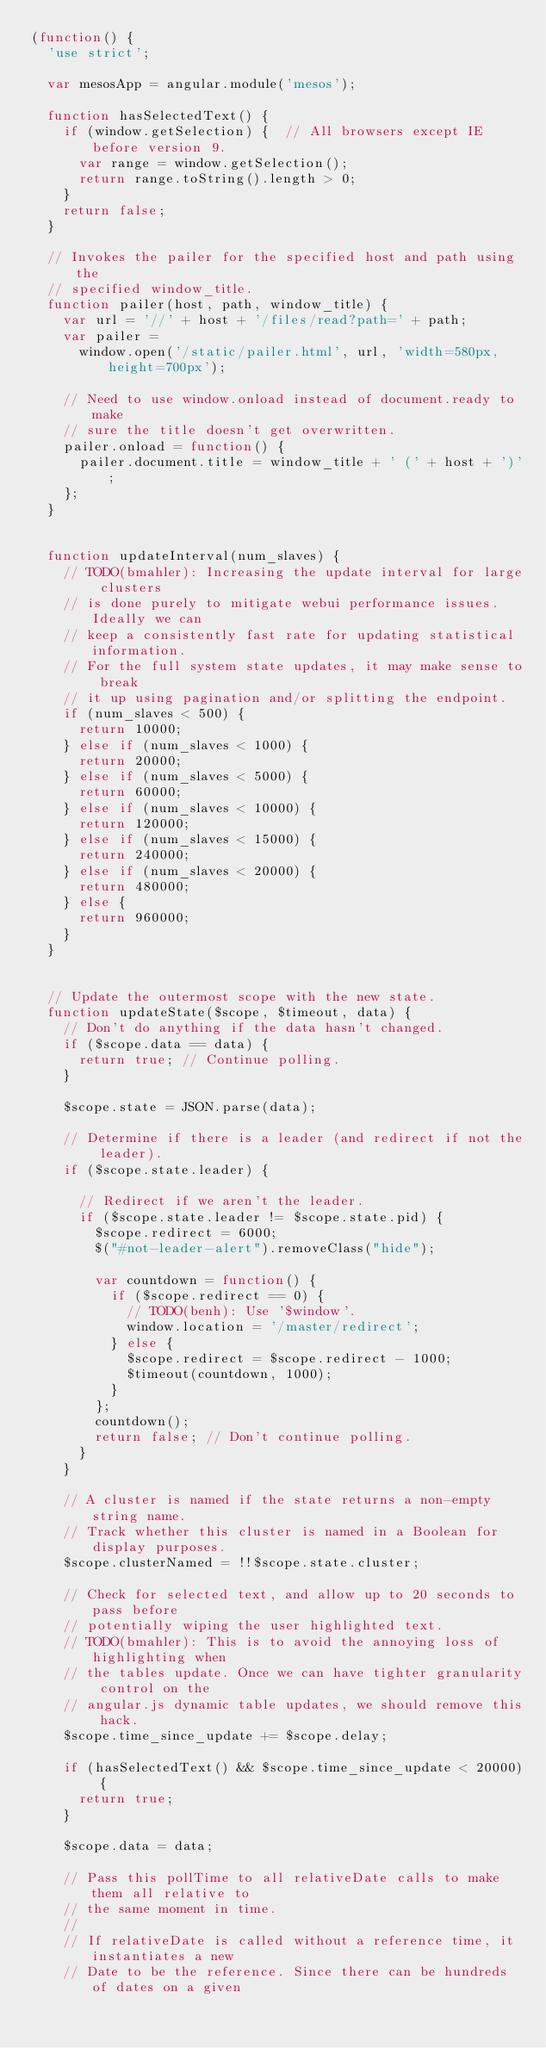<code> <loc_0><loc_0><loc_500><loc_500><_JavaScript_>(function() {
  'use strict';

  var mesosApp = angular.module('mesos');

  function hasSelectedText() {
    if (window.getSelection) {  // All browsers except IE before version 9.
      var range = window.getSelection();
      return range.toString().length > 0;
    }
    return false;
  }

  // Invokes the pailer for the specified host and path using the
  // specified window_title.
  function pailer(host, path, window_title) {
    var url = '//' + host + '/files/read?path=' + path;
    var pailer =
      window.open('/static/pailer.html', url, 'width=580px, height=700px');

    // Need to use window.onload instead of document.ready to make
    // sure the title doesn't get overwritten.
    pailer.onload = function() {
      pailer.document.title = window_title + ' (' + host + ')';
    };
  }


  function updateInterval(num_slaves) {
    // TODO(bmahler): Increasing the update interval for large clusters
    // is done purely to mitigate webui performance issues. Ideally we can
    // keep a consistently fast rate for updating statistical information.
    // For the full system state updates, it may make sense to break
    // it up using pagination and/or splitting the endpoint.
    if (num_slaves < 500) {
      return 10000;
    } else if (num_slaves < 1000) {
      return 20000;
    } else if (num_slaves < 5000) {
      return 60000;
    } else if (num_slaves < 10000) {
      return 120000;
    } else if (num_slaves < 15000) {
      return 240000;
    } else if (num_slaves < 20000) {
      return 480000;
    } else {
      return 960000;
    }
  }


  // Update the outermost scope with the new state.
  function updateState($scope, $timeout, data) {
    // Don't do anything if the data hasn't changed.
    if ($scope.data == data) {
      return true; // Continue polling.
    }

    $scope.state = JSON.parse(data);

    // Determine if there is a leader (and redirect if not the leader).
    if ($scope.state.leader) {

      // Redirect if we aren't the leader.
      if ($scope.state.leader != $scope.state.pid) {
        $scope.redirect = 6000;
        $("#not-leader-alert").removeClass("hide");

        var countdown = function() {
          if ($scope.redirect == 0) {
            // TODO(benh): Use '$window'.
            window.location = '/master/redirect';
          } else {
            $scope.redirect = $scope.redirect - 1000;
            $timeout(countdown, 1000);
          }
        };
        countdown();
        return false; // Don't continue polling.
      }
    }

    // A cluster is named if the state returns a non-empty string name.
    // Track whether this cluster is named in a Boolean for display purposes.
    $scope.clusterNamed = !!$scope.state.cluster;

    // Check for selected text, and allow up to 20 seconds to pass before
    // potentially wiping the user highlighted text.
    // TODO(bmahler): This is to avoid the annoying loss of highlighting when
    // the tables update. Once we can have tighter granularity control on the
    // angular.js dynamic table updates, we should remove this hack.
    $scope.time_since_update += $scope.delay;

    if (hasSelectedText() && $scope.time_since_update < 20000) {
      return true;
    }

    $scope.data = data;

    // Pass this pollTime to all relativeDate calls to make them all relative to
    // the same moment in time.
    //
    // If relativeDate is called without a reference time, it instantiates a new
    // Date to be the reference. Since there can be hundreds of dates on a given</code> 